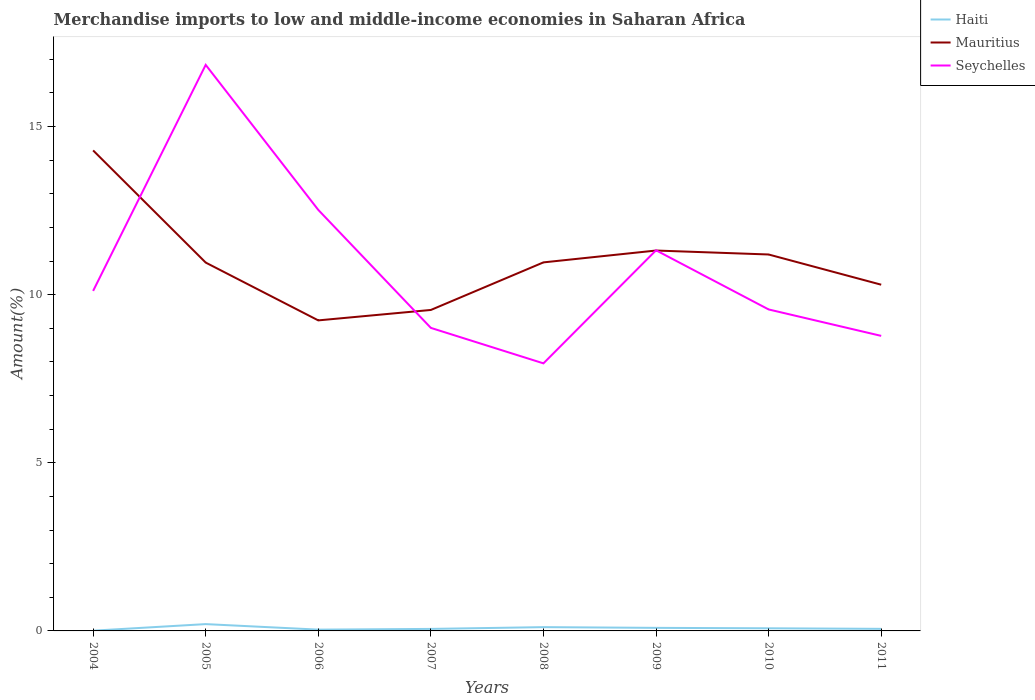How many different coloured lines are there?
Make the answer very short. 3. Does the line corresponding to Haiti intersect with the line corresponding to Seychelles?
Provide a short and direct response. No. Across all years, what is the maximum percentage of amount earned from merchandise imports in Mauritius?
Make the answer very short. 9.23. What is the total percentage of amount earned from merchandise imports in Mauritius in the graph?
Give a very brief answer. -0.24. What is the difference between the highest and the second highest percentage of amount earned from merchandise imports in Haiti?
Ensure brevity in your answer.  0.2. What is the difference between the highest and the lowest percentage of amount earned from merchandise imports in Haiti?
Offer a very short reply. 3. How many lines are there?
Provide a succinct answer. 3. How many years are there in the graph?
Your response must be concise. 8. Are the values on the major ticks of Y-axis written in scientific E-notation?
Offer a terse response. No. Does the graph contain any zero values?
Give a very brief answer. No. Does the graph contain grids?
Provide a short and direct response. No. Where does the legend appear in the graph?
Keep it short and to the point. Top right. How are the legend labels stacked?
Give a very brief answer. Vertical. What is the title of the graph?
Offer a very short reply. Merchandise imports to low and middle-income economies in Saharan Africa. What is the label or title of the Y-axis?
Make the answer very short. Amount(%). What is the Amount(%) in Haiti in 2004?
Your answer should be very brief. 0.01. What is the Amount(%) in Mauritius in 2004?
Offer a very short reply. 14.29. What is the Amount(%) of Seychelles in 2004?
Offer a very short reply. 10.11. What is the Amount(%) of Haiti in 2005?
Make the answer very short. 0.2. What is the Amount(%) in Mauritius in 2005?
Provide a short and direct response. 10.95. What is the Amount(%) of Seychelles in 2005?
Make the answer very short. 16.83. What is the Amount(%) in Haiti in 2006?
Ensure brevity in your answer.  0.04. What is the Amount(%) of Mauritius in 2006?
Make the answer very short. 9.23. What is the Amount(%) of Seychelles in 2006?
Offer a very short reply. 12.52. What is the Amount(%) in Haiti in 2007?
Keep it short and to the point. 0.06. What is the Amount(%) in Mauritius in 2007?
Ensure brevity in your answer.  9.55. What is the Amount(%) in Seychelles in 2007?
Make the answer very short. 9.01. What is the Amount(%) of Haiti in 2008?
Offer a very short reply. 0.11. What is the Amount(%) of Mauritius in 2008?
Your answer should be compact. 10.96. What is the Amount(%) of Seychelles in 2008?
Make the answer very short. 7.96. What is the Amount(%) of Haiti in 2009?
Make the answer very short. 0.09. What is the Amount(%) of Mauritius in 2009?
Offer a very short reply. 11.31. What is the Amount(%) in Seychelles in 2009?
Keep it short and to the point. 11.32. What is the Amount(%) in Haiti in 2010?
Your answer should be compact. 0.08. What is the Amount(%) in Mauritius in 2010?
Your answer should be compact. 11.19. What is the Amount(%) of Seychelles in 2010?
Give a very brief answer. 9.56. What is the Amount(%) of Haiti in 2011?
Ensure brevity in your answer.  0.06. What is the Amount(%) in Mauritius in 2011?
Offer a very short reply. 10.3. What is the Amount(%) in Seychelles in 2011?
Offer a terse response. 8.77. Across all years, what is the maximum Amount(%) in Haiti?
Offer a terse response. 0.2. Across all years, what is the maximum Amount(%) of Mauritius?
Provide a short and direct response. 14.29. Across all years, what is the maximum Amount(%) of Seychelles?
Give a very brief answer. 16.83. Across all years, what is the minimum Amount(%) in Haiti?
Make the answer very short. 0.01. Across all years, what is the minimum Amount(%) in Mauritius?
Keep it short and to the point. 9.23. Across all years, what is the minimum Amount(%) in Seychelles?
Offer a terse response. 7.96. What is the total Amount(%) in Haiti in the graph?
Make the answer very short. 0.65. What is the total Amount(%) of Mauritius in the graph?
Your answer should be compact. 87.79. What is the total Amount(%) of Seychelles in the graph?
Provide a short and direct response. 86.09. What is the difference between the Amount(%) in Haiti in 2004 and that in 2005?
Your answer should be very brief. -0.2. What is the difference between the Amount(%) of Mauritius in 2004 and that in 2005?
Keep it short and to the point. 3.34. What is the difference between the Amount(%) in Seychelles in 2004 and that in 2005?
Offer a terse response. -6.72. What is the difference between the Amount(%) in Haiti in 2004 and that in 2006?
Your answer should be compact. -0.03. What is the difference between the Amount(%) in Mauritius in 2004 and that in 2006?
Your response must be concise. 5.05. What is the difference between the Amount(%) of Seychelles in 2004 and that in 2006?
Your answer should be very brief. -2.41. What is the difference between the Amount(%) in Haiti in 2004 and that in 2007?
Give a very brief answer. -0.05. What is the difference between the Amount(%) of Mauritius in 2004 and that in 2007?
Provide a short and direct response. 4.74. What is the difference between the Amount(%) of Seychelles in 2004 and that in 2007?
Keep it short and to the point. 1.1. What is the difference between the Amount(%) in Haiti in 2004 and that in 2008?
Your answer should be compact. -0.11. What is the difference between the Amount(%) in Mauritius in 2004 and that in 2008?
Your response must be concise. 3.33. What is the difference between the Amount(%) of Seychelles in 2004 and that in 2008?
Make the answer very short. 2.15. What is the difference between the Amount(%) in Haiti in 2004 and that in 2009?
Make the answer very short. -0.08. What is the difference between the Amount(%) of Mauritius in 2004 and that in 2009?
Give a very brief answer. 2.98. What is the difference between the Amount(%) in Seychelles in 2004 and that in 2009?
Offer a very short reply. -1.21. What is the difference between the Amount(%) in Haiti in 2004 and that in 2010?
Make the answer very short. -0.07. What is the difference between the Amount(%) of Mauritius in 2004 and that in 2010?
Your response must be concise. 3.1. What is the difference between the Amount(%) in Seychelles in 2004 and that in 2010?
Provide a succinct answer. 0.55. What is the difference between the Amount(%) of Haiti in 2004 and that in 2011?
Provide a short and direct response. -0.05. What is the difference between the Amount(%) in Mauritius in 2004 and that in 2011?
Offer a very short reply. 3.99. What is the difference between the Amount(%) in Seychelles in 2004 and that in 2011?
Ensure brevity in your answer.  1.34. What is the difference between the Amount(%) in Haiti in 2005 and that in 2006?
Ensure brevity in your answer.  0.16. What is the difference between the Amount(%) in Mauritius in 2005 and that in 2006?
Your answer should be compact. 1.72. What is the difference between the Amount(%) in Seychelles in 2005 and that in 2006?
Your answer should be very brief. 4.31. What is the difference between the Amount(%) of Haiti in 2005 and that in 2007?
Ensure brevity in your answer.  0.14. What is the difference between the Amount(%) in Mauritius in 2005 and that in 2007?
Offer a very short reply. 1.41. What is the difference between the Amount(%) of Seychelles in 2005 and that in 2007?
Your answer should be very brief. 7.82. What is the difference between the Amount(%) in Haiti in 2005 and that in 2008?
Make the answer very short. 0.09. What is the difference between the Amount(%) in Mauritius in 2005 and that in 2008?
Your answer should be compact. -0.01. What is the difference between the Amount(%) in Seychelles in 2005 and that in 2008?
Make the answer very short. 8.88. What is the difference between the Amount(%) in Haiti in 2005 and that in 2009?
Ensure brevity in your answer.  0.11. What is the difference between the Amount(%) of Mauritius in 2005 and that in 2009?
Keep it short and to the point. -0.36. What is the difference between the Amount(%) in Seychelles in 2005 and that in 2009?
Your response must be concise. 5.51. What is the difference between the Amount(%) in Haiti in 2005 and that in 2010?
Provide a short and direct response. 0.12. What is the difference between the Amount(%) of Mauritius in 2005 and that in 2010?
Provide a short and direct response. -0.24. What is the difference between the Amount(%) in Seychelles in 2005 and that in 2010?
Offer a terse response. 7.27. What is the difference between the Amount(%) in Haiti in 2005 and that in 2011?
Make the answer very short. 0.14. What is the difference between the Amount(%) in Mauritius in 2005 and that in 2011?
Keep it short and to the point. 0.66. What is the difference between the Amount(%) in Seychelles in 2005 and that in 2011?
Your answer should be very brief. 8.06. What is the difference between the Amount(%) of Haiti in 2006 and that in 2007?
Offer a very short reply. -0.02. What is the difference between the Amount(%) in Mauritius in 2006 and that in 2007?
Offer a terse response. -0.31. What is the difference between the Amount(%) in Seychelles in 2006 and that in 2007?
Give a very brief answer. 3.51. What is the difference between the Amount(%) in Haiti in 2006 and that in 2008?
Keep it short and to the point. -0.07. What is the difference between the Amount(%) in Mauritius in 2006 and that in 2008?
Offer a very short reply. -1.73. What is the difference between the Amount(%) of Seychelles in 2006 and that in 2008?
Give a very brief answer. 4.56. What is the difference between the Amount(%) of Haiti in 2006 and that in 2009?
Ensure brevity in your answer.  -0.05. What is the difference between the Amount(%) in Mauritius in 2006 and that in 2009?
Offer a very short reply. -2.08. What is the difference between the Amount(%) in Seychelles in 2006 and that in 2009?
Offer a very short reply. 1.2. What is the difference between the Amount(%) in Haiti in 2006 and that in 2010?
Make the answer very short. -0.04. What is the difference between the Amount(%) in Mauritius in 2006 and that in 2010?
Your answer should be very brief. -1.96. What is the difference between the Amount(%) of Seychelles in 2006 and that in 2010?
Ensure brevity in your answer.  2.96. What is the difference between the Amount(%) of Haiti in 2006 and that in 2011?
Provide a succinct answer. -0.02. What is the difference between the Amount(%) in Mauritius in 2006 and that in 2011?
Make the answer very short. -1.06. What is the difference between the Amount(%) in Seychelles in 2006 and that in 2011?
Offer a very short reply. 3.75. What is the difference between the Amount(%) of Haiti in 2007 and that in 2008?
Your response must be concise. -0.05. What is the difference between the Amount(%) of Mauritius in 2007 and that in 2008?
Ensure brevity in your answer.  -1.41. What is the difference between the Amount(%) of Seychelles in 2007 and that in 2008?
Keep it short and to the point. 1.05. What is the difference between the Amount(%) in Haiti in 2007 and that in 2009?
Make the answer very short. -0.03. What is the difference between the Amount(%) in Mauritius in 2007 and that in 2009?
Provide a short and direct response. -1.77. What is the difference between the Amount(%) of Seychelles in 2007 and that in 2009?
Your answer should be very brief. -2.31. What is the difference between the Amount(%) in Haiti in 2007 and that in 2010?
Your answer should be very brief. -0.02. What is the difference between the Amount(%) in Mauritius in 2007 and that in 2010?
Ensure brevity in your answer.  -1.65. What is the difference between the Amount(%) of Seychelles in 2007 and that in 2010?
Your response must be concise. -0.55. What is the difference between the Amount(%) in Haiti in 2007 and that in 2011?
Offer a very short reply. -0. What is the difference between the Amount(%) of Mauritius in 2007 and that in 2011?
Provide a succinct answer. -0.75. What is the difference between the Amount(%) of Seychelles in 2007 and that in 2011?
Your answer should be very brief. 0.24. What is the difference between the Amount(%) in Haiti in 2008 and that in 2009?
Keep it short and to the point. 0.02. What is the difference between the Amount(%) of Mauritius in 2008 and that in 2009?
Offer a terse response. -0.35. What is the difference between the Amount(%) in Seychelles in 2008 and that in 2009?
Give a very brief answer. -3.36. What is the difference between the Amount(%) of Haiti in 2008 and that in 2010?
Offer a terse response. 0.03. What is the difference between the Amount(%) in Mauritius in 2008 and that in 2010?
Your response must be concise. -0.23. What is the difference between the Amount(%) of Seychelles in 2008 and that in 2010?
Your answer should be compact. -1.6. What is the difference between the Amount(%) in Haiti in 2008 and that in 2011?
Keep it short and to the point. 0.05. What is the difference between the Amount(%) in Mauritius in 2008 and that in 2011?
Give a very brief answer. 0.66. What is the difference between the Amount(%) in Seychelles in 2008 and that in 2011?
Your answer should be very brief. -0.82. What is the difference between the Amount(%) of Haiti in 2009 and that in 2010?
Provide a short and direct response. 0.01. What is the difference between the Amount(%) in Mauritius in 2009 and that in 2010?
Offer a very short reply. 0.12. What is the difference between the Amount(%) in Seychelles in 2009 and that in 2010?
Give a very brief answer. 1.76. What is the difference between the Amount(%) in Haiti in 2009 and that in 2011?
Your answer should be compact. 0.03. What is the difference between the Amount(%) in Mauritius in 2009 and that in 2011?
Make the answer very short. 1.02. What is the difference between the Amount(%) of Seychelles in 2009 and that in 2011?
Keep it short and to the point. 2.55. What is the difference between the Amount(%) of Haiti in 2010 and that in 2011?
Ensure brevity in your answer.  0.02. What is the difference between the Amount(%) of Mauritius in 2010 and that in 2011?
Provide a short and direct response. 0.9. What is the difference between the Amount(%) in Seychelles in 2010 and that in 2011?
Make the answer very short. 0.79. What is the difference between the Amount(%) in Haiti in 2004 and the Amount(%) in Mauritius in 2005?
Your answer should be compact. -10.95. What is the difference between the Amount(%) in Haiti in 2004 and the Amount(%) in Seychelles in 2005?
Offer a terse response. -16.83. What is the difference between the Amount(%) in Mauritius in 2004 and the Amount(%) in Seychelles in 2005?
Offer a terse response. -2.54. What is the difference between the Amount(%) in Haiti in 2004 and the Amount(%) in Mauritius in 2006?
Your answer should be very brief. -9.23. What is the difference between the Amount(%) in Haiti in 2004 and the Amount(%) in Seychelles in 2006?
Provide a short and direct response. -12.51. What is the difference between the Amount(%) in Mauritius in 2004 and the Amount(%) in Seychelles in 2006?
Offer a very short reply. 1.77. What is the difference between the Amount(%) in Haiti in 2004 and the Amount(%) in Mauritius in 2007?
Give a very brief answer. -9.54. What is the difference between the Amount(%) of Haiti in 2004 and the Amount(%) of Seychelles in 2007?
Keep it short and to the point. -9. What is the difference between the Amount(%) in Mauritius in 2004 and the Amount(%) in Seychelles in 2007?
Your answer should be very brief. 5.28. What is the difference between the Amount(%) of Haiti in 2004 and the Amount(%) of Mauritius in 2008?
Offer a very short reply. -10.95. What is the difference between the Amount(%) in Haiti in 2004 and the Amount(%) in Seychelles in 2008?
Your answer should be very brief. -7.95. What is the difference between the Amount(%) in Mauritius in 2004 and the Amount(%) in Seychelles in 2008?
Keep it short and to the point. 6.33. What is the difference between the Amount(%) of Haiti in 2004 and the Amount(%) of Mauritius in 2009?
Your answer should be very brief. -11.3. What is the difference between the Amount(%) of Haiti in 2004 and the Amount(%) of Seychelles in 2009?
Your answer should be very brief. -11.31. What is the difference between the Amount(%) in Mauritius in 2004 and the Amount(%) in Seychelles in 2009?
Your answer should be compact. 2.97. What is the difference between the Amount(%) of Haiti in 2004 and the Amount(%) of Mauritius in 2010?
Give a very brief answer. -11.19. What is the difference between the Amount(%) in Haiti in 2004 and the Amount(%) in Seychelles in 2010?
Give a very brief answer. -9.55. What is the difference between the Amount(%) of Mauritius in 2004 and the Amount(%) of Seychelles in 2010?
Make the answer very short. 4.73. What is the difference between the Amount(%) in Haiti in 2004 and the Amount(%) in Mauritius in 2011?
Offer a very short reply. -10.29. What is the difference between the Amount(%) of Haiti in 2004 and the Amount(%) of Seychelles in 2011?
Your response must be concise. -8.77. What is the difference between the Amount(%) in Mauritius in 2004 and the Amount(%) in Seychelles in 2011?
Ensure brevity in your answer.  5.52. What is the difference between the Amount(%) of Haiti in 2005 and the Amount(%) of Mauritius in 2006?
Keep it short and to the point. -9.03. What is the difference between the Amount(%) in Haiti in 2005 and the Amount(%) in Seychelles in 2006?
Offer a very short reply. -12.32. What is the difference between the Amount(%) of Mauritius in 2005 and the Amount(%) of Seychelles in 2006?
Make the answer very short. -1.57. What is the difference between the Amount(%) of Haiti in 2005 and the Amount(%) of Mauritius in 2007?
Offer a terse response. -9.34. What is the difference between the Amount(%) of Haiti in 2005 and the Amount(%) of Seychelles in 2007?
Ensure brevity in your answer.  -8.81. What is the difference between the Amount(%) of Mauritius in 2005 and the Amount(%) of Seychelles in 2007?
Your answer should be very brief. 1.94. What is the difference between the Amount(%) in Haiti in 2005 and the Amount(%) in Mauritius in 2008?
Make the answer very short. -10.76. What is the difference between the Amount(%) in Haiti in 2005 and the Amount(%) in Seychelles in 2008?
Your answer should be very brief. -7.75. What is the difference between the Amount(%) in Mauritius in 2005 and the Amount(%) in Seychelles in 2008?
Provide a succinct answer. 3. What is the difference between the Amount(%) of Haiti in 2005 and the Amount(%) of Mauritius in 2009?
Keep it short and to the point. -11.11. What is the difference between the Amount(%) in Haiti in 2005 and the Amount(%) in Seychelles in 2009?
Provide a succinct answer. -11.12. What is the difference between the Amount(%) of Mauritius in 2005 and the Amount(%) of Seychelles in 2009?
Offer a very short reply. -0.36. What is the difference between the Amount(%) of Haiti in 2005 and the Amount(%) of Mauritius in 2010?
Offer a terse response. -10.99. What is the difference between the Amount(%) of Haiti in 2005 and the Amount(%) of Seychelles in 2010?
Offer a very short reply. -9.36. What is the difference between the Amount(%) in Mauritius in 2005 and the Amount(%) in Seychelles in 2010?
Your answer should be compact. 1.39. What is the difference between the Amount(%) in Haiti in 2005 and the Amount(%) in Mauritius in 2011?
Make the answer very short. -10.09. What is the difference between the Amount(%) of Haiti in 2005 and the Amount(%) of Seychelles in 2011?
Your answer should be compact. -8.57. What is the difference between the Amount(%) of Mauritius in 2005 and the Amount(%) of Seychelles in 2011?
Your answer should be compact. 2.18. What is the difference between the Amount(%) in Haiti in 2006 and the Amount(%) in Mauritius in 2007?
Make the answer very short. -9.51. What is the difference between the Amount(%) of Haiti in 2006 and the Amount(%) of Seychelles in 2007?
Offer a very short reply. -8.97. What is the difference between the Amount(%) of Mauritius in 2006 and the Amount(%) of Seychelles in 2007?
Give a very brief answer. 0.22. What is the difference between the Amount(%) of Haiti in 2006 and the Amount(%) of Mauritius in 2008?
Offer a very short reply. -10.92. What is the difference between the Amount(%) in Haiti in 2006 and the Amount(%) in Seychelles in 2008?
Make the answer very short. -7.92. What is the difference between the Amount(%) in Mauritius in 2006 and the Amount(%) in Seychelles in 2008?
Provide a succinct answer. 1.28. What is the difference between the Amount(%) in Haiti in 2006 and the Amount(%) in Mauritius in 2009?
Offer a terse response. -11.27. What is the difference between the Amount(%) of Haiti in 2006 and the Amount(%) of Seychelles in 2009?
Your response must be concise. -11.28. What is the difference between the Amount(%) of Mauritius in 2006 and the Amount(%) of Seychelles in 2009?
Offer a very short reply. -2.08. What is the difference between the Amount(%) in Haiti in 2006 and the Amount(%) in Mauritius in 2010?
Provide a succinct answer. -11.16. What is the difference between the Amount(%) in Haiti in 2006 and the Amount(%) in Seychelles in 2010?
Keep it short and to the point. -9.52. What is the difference between the Amount(%) of Mauritius in 2006 and the Amount(%) of Seychelles in 2010?
Your response must be concise. -0.33. What is the difference between the Amount(%) of Haiti in 2006 and the Amount(%) of Mauritius in 2011?
Ensure brevity in your answer.  -10.26. What is the difference between the Amount(%) of Haiti in 2006 and the Amount(%) of Seychelles in 2011?
Give a very brief answer. -8.74. What is the difference between the Amount(%) of Mauritius in 2006 and the Amount(%) of Seychelles in 2011?
Ensure brevity in your answer.  0.46. What is the difference between the Amount(%) of Haiti in 2007 and the Amount(%) of Mauritius in 2008?
Your answer should be very brief. -10.9. What is the difference between the Amount(%) in Haiti in 2007 and the Amount(%) in Seychelles in 2008?
Your response must be concise. -7.9. What is the difference between the Amount(%) in Mauritius in 2007 and the Amount(%) in Seychelles in 2008?
Keep it short and to the point. 1.59. What is the difference between the Amount(%) in Haiti in 2007 and the Amount(%) in Mauritius in 2009?
Offer a terse response. -11.25. What is the difference between the Amount(%) in Haiti in 2007 and the Amount(%) in Seychelles in 2009?
Ensure brevity in your answer.  -11.26. What is the difference between the Amount(%) in Mauritius in 2007 and the Amount(%) in Seychelles in 2009?
Offer a very short reply. -1.77. What is the difference between the Amount(%) of Haiti in 2007 and the Amount(%) of Mauritius in 2010?
Your answer should be very brief. -11.13. What is the difference between the Amount(%) in Haiti in 2007 and the Amount(%) in Seychelles in 2010?
Keep it short and to the point. -9.5. What is the difference between the Amount(%) of Mauritius in 2007 and the Amount(%) of Seychelles in 2010?
Offer a terse response. -0.02. What is the difference between the Amount(%) in Haiti in 2007 and the Amount(%) in Mauritius in 2011?
Give a very brief answer. -10.24. What is the difference between the Amount(%) of Haiti in 2007 and the Amount(%) of Seychelles in 2011?
Provide a short and direct response. -8.71. What is the difference between the Amount(%) in Mauritius in 2007 and the Amount(%) in Seychelles in 2011?
Ensure brevity in your answer.  0.77. What is the difference between the Amount(%) in Haiti in 2008 and the Amount(%) in Mauritius in 2009?
Offer a terse response. -11.2. What is the difference between the Amount(%) in Haiti in 2008 and the Amount(%) in Seychelles in 2009?
Provide a succinct answer. -11.21. What is the difference between the Amount(%) of Mauritius in 2008 and the Amount(%) of Seychelles in 2009?
Your response must be concise. -0.36. What is the difference between the Amount(%) in Haiti in 2008 and the Amount(%) in Mauritius in 2010?
Offer a terse response. -11.08. What is the difference between the Amount(%) in Haiti in 2008 and the Amount(%) in Seychelles in 2010?
Make the answer very short. -9.45. What is the difference between the Amount(%) of Mauritius in 2008 and the Amount(%) of Seychelles in 2010?
Ensure brevity in your answer.  1.4. What is the difference between the Amount(%) in Haiti in 2008 and the Amount(%) in Mauritius in 2011?
Provide a short and direct response. -10.18. What is the difference between the Amount(%) of Haiti in 2008 and the Amount(%) of Seychelles in 2011?
Your answer should be compact. -8.66. What is the difference between the Amount(%) in Mauritius in 2008 and the Amount(%) in Seychelles in 2011?
Your answer should be compact. 2.19. What is the difference between the Amount(%) of Haiti in 2009 and the Amount(%) of Mauritius in 2010?
Provide a succinct answer. -11.1. What is the difference between the Amount(%) in Haiti in 2009 and the Amount(%) in Seychelles in 2010?
Provide a succinct answer. -9.47. What is the difference between the Amount(%) of Mauritius in 2009 and the Amount(%) of Seychelles in 2010?
Your answer should be compact. 1.75. What is the difference between the Amount(%) of Haiti in 2009 and the Amount(%) of Mauritius in 2011?
Give a very brief answer. -10.2. What is the difference between the Amount(%) of Haiti in 2009 and the Amount(%) of Seychelles in 2011?
Offer a very short reply. -8.68. What is the difference between the Amount(%) of Mauritius in 2009 and the Amount(%) of Seychelles in 2011?
Offer a very short reply. 2.54. What is the difference between the Amount(%) in Haiti in 2010 and the Amount(%) in Mauritius in 2011?
Your response must be concise. -10.22. What is the difference between the Amount(%) of Haiti in 2010 and the Amount(%) of Seychelles in 2011?
Offer a terse response. -8.7. What is the difference between the Amount(%) of Mauritius in 2010 and the Amount(%) of Seychelles in 2011?
Keep it short and to the point. 2.42. What is the average Amount(%) in Haiti per year?
Make the answer very short. 0.08. What is the average Amount(%) in Mauritius per year?
Ensure brevity in your answer.  10.97. What is the average Amount(%) in Seychelles per year?
Your answer should be compact. 10.76. In the year 2004, what is the difference between the Amount(%) of Haiti and Amount(%) of Mauritius?
Make the answer very short. -14.28. In the year 2004, what is the difference between the Amount(%) of Haiti and Amount(%) of Seychelles?
Offer a very short reply. -10.1. In the year 2004, what is the difference between the Amount(%) of Mauritius and Amount(%) of Seychelles?
Your answer should be compact. 4.18. In the year 2005, what is the difference between the Amount(%) in Haiti and Amount(%) in Mauritius?
Give a very brief answer. -10.75. In the year 2005, what is the difference between the Amount(%) of Haiti and Amount(%) of Seychelles?
Offer a very short reply. -16.63. In the year 2005, what is the difference between the Amount(%) in Mauritius and Amount(%) in Seychelles?
Give a very brief answer. -5.88. In the year 2006, what is the difference between the Amount(%) in Haiti and Amount(%) in Mauritius?
Ensure brevity in your answer.  -9.2. In the year 2006, what is the difference between the Amount(%) in Haiti and Amount(%) in Seychelles?
Your answer should be compact. -12.48. In the year 2006, what is the difference between the Amount(%) of Mauritius and Amount(%) of Seychelles?
Keep it short and to the point. -3.29. In the year 2007, what is the difference between the Amount(%) of Haiti and Amount(%) of Mauritius?
Offer a terse response. -9.49. In the year 2007, what is the difference between the Amount(%) of Haiti and Amount(%) of Seychelles?
Your response must be concise. -8.95. In the year 2007, what is the difference between the Amount(%) in Mauritius and Amount(%) in Seychelles?
Keep it short and to the point. 0.53. In the year 2008, what is the difference between the Amount(%) of Haiti and Amount(%) of Mauritius?
Give a very brief answer. -10.85. In the year 2008, what is the difference between the Amount(%) in Haiti and Amount(%) in Seychelles?
Provide a short and direct response. -7.84. In the year 2008, what is the difference between the Amount(%) of Mauritius and Amount(%) of Seychelles?
Your answer should be compact. 3. In the year 2009, what is the difference between the Amount(%) of Haiti and Amount(%) of Mauritius?
Offer a very short reply. -11.22. In the year 2009, what is the difference between the Amount(%) in Haiti and Amount(%) in Seychelles?
Your answer should be compact. -11.23. In the year 2009, what is the difference between the Amount(%) of Mauritius and Amount(%) of Seychelles?
Keep it short and to the point. -0.01. In the year 2010, what is the difference between the Amount(%) of Haiti and Amount(%) of Mauritius?
Your answer should be compact. -11.12. In the year 2010, what is the difference between the Amount(%) of Haiti and Amount(%) of Seychelles?
Ensure brevity in your answer.  -9.48. In the year 2010, what is the difference between the Amount(%) of Mauritius and Amount(%) of Seychelles?
Provide a short and direct response. 1.63. In the year 2011, what is the difference between the Amount(%) of Haiti and Amount(%) of Mauritius?
Your response must be concise. -10.23. In the year 2011, what is the difference between the Amount(%) in Haiti and Amount(%) in Seychelles?
Provide a succinct answer. -8.71. In the year 2011, what is the difference between the Amount(%) of Mauritius and Amount(%) of Seychelles?
Offer a terse response. 1.52. What is the ratio of the Amount(%) of Haiti in 2004 to that in 2005?
Your response must be concise. 0.04. What is the ratio of the Amount(%) of Mauritius in 2004 to that in 2005?
Give a very brief answer. 1.3. What is the ratio of the Amount(%) of Seychelles in 2004 to that in 2005?
Your answer should be compact. 0.6. What is the ratio of the Amount(%) of Haiti in 2004 to that in 2006?
Offer a terse response. 0.19. What is the ratio of the Amount(%) in Mauritius in 2004 to that in 2006?
Provide a succinct answer. 1.55. What is the ratio of the Amount(%) of Seychelles in 2004 to that in 2006?
Give a very brief answer. 0.81. What is the ratio of the Amount(%) of Haiti in 2004 to that in 2007?
Give a very brief answer. 0.12. What is the ratio of the Amount(%) in Mauritius in 2004 to that in 2007?
Offer a very short reply. 1.5. What is the ratio of the Amount(%) of Seychelles in 2004 to that in 2007?
Keep it short and to the point. 1.12. What is the ratio of the Amount(%) in Haiti in 2004 to that in 2008?
Provide a short and direct response. 0.06. What is the ratio of the Amount(%) in Mauritius in 2004 to that in 2008?
Your answer should be very brief. 1.3. What is the ratio of the Amount(%) of Seychelles in 2004 to that in 2008?
Provide a succinct answer. 1.27. What is the ratio of the Amount(%) of Haiti in 2004 to that in 2009?
Ensure brevity in your answer.  0.08. What is the ratio of the Amount(%) of Mauritius in 2004 to that in 2009?
Offer a terse response. 1.26. What is the ratio of the Amount(%) of Seychelles in 2004 to that in 2009?
Your answer should be compact. 0.89. What is the ratio of the Amount(%) in Haiti in 2004 to that in 2010?
Your answer should be very brief. 0.09. What is the ratio of the Amount(%) in Mauritius in 2004 to that in 2010?
Make the answer very short. 1.28. What is the ratio of the Amount(%) of Seychelles in 2004 to that in 2010?
Offer a terse response. 1.06. What is the ratio of the Amount(%) in Haiti in 2004 to that in 2011?
Your answer should be very brief. 0.12. What is the ratio of the Amount(%) of Mauritius in 2004 to that in 2011?
Provide a short and direct response. 1.39. What is the ratio of the Amount(%) in Seychelles in 2004 to that in 2011?
Offer a terse response. 1.15. What is the ratio of the Amount(%) of Haiti in 2005 to that in 2006?
Ensure brevity in your answer.  5.26. What is the ratio of the Amount(%) of Mauritius in 2005 to that in 2006?
Ensure brevity in your answer.  1.19. What is the ratio of the Amount(%) in Seychelles in 2005 to that in 2006?
Provide a succinct answer. 1.34. What is the ratio of the Amount(%) in Haiti in 2005 to that in 2007?
Your answer should be compact. 3.39. What is the ratio of the Amount(%) in Mauritius in 2005 to that in 2007?
Provide a succinct answer. 1.15. What is the ratio of the Amount(%) in Seychelles in 2005 to that in 2007?
Offer a very short reply. 1.87. What is the ratio of the Amount(%) of Haiti in 2005 to that in 2008?
Provide a short and direct response. 1.8. What is the ratio of the Amount(%) in Mauritius in 2005 to that in 2008?
Ensure brevity in your answer.  1. What is the ratio of the Amount(%) of Seychelles in 2005 to that in 2008?
Your response must be concise. 2.12. What is the ratio of the Amount(%) in Haiti in 2005 to that in 2009?
Offer a very short reply. 2.22. What is the ratio of the Amount(%) in Mauritius in 2005 to that in 2009?
Your answer should be compact. 0.97. What is the ratio of the Amount(%) of Seychelles in 2005 to that in 2009?
Your response must be concise. 1.49. What is the ratio of the Amount(%) of Haiti in 2005 to that in 2010?
Your answer should be very brief. 2.6. What is the ratio of the Amount(%) in Mauritius in 2005 to that in 2010?
Offer a terse response. 0.98. What is the ratio of the Amount(%) of Seychelles in 2005 to that in 2010?
Provide a short and direct response. 1.76. What is the ratio of the Amount(%) of Haiti in 2005 to that in 2011?
Your answer should be compact. 3.29. What is the ratio of the Amount(%) of Mauritius in 2005 to that in 2011?
Give a very brief answer. 1.06. What is the ratio of the Amount(%) in Seychelles in 2005 to that in 2011?
Provide a short and direct response. 1.92. What is the ratio of the Amount(%) of Haiti in 2006 to that in 2007?
Keep it short and to the point. 0.65. What is the ratio of the Amount(%) of Mauritius in 2006 to that in 2007?
Give a very brief answer. 0.97. What is the ratio of the Amount(%) in Seychelles in 2006 to that in 2007?
Ensure brevity in your answer.  1.39. What is the ratio of the Amount(%) in Haiti in 2006 to that in 2008?
Ensure brevity in your answer.  0.34. What is the ratio of the Amount(%) in Mauritius in 2006 to that in 2008?
Provide a succinct answer. 0.84. What is the ratio of the Amount(%) in Seychelles in 2006 to that in 2008?
Offer a very short reply. 1.57. What is the ratio of the Amount(%) in Haiti in 2006 to that in 2009?
Offer a very short reply. 0.42. What is the ratio of the Amount(%) in Mauritius in 2006 to that in 2009?
Provide a short and direct response. 0.82. What is the ratio of the Amount(%) of Seychelles in 2006 to that in 2009?
Offer a terse response. 1.11. What is the ratio of the Amount(%) in Haiti in 2006 to that in 2010?
Keep it short and to the point. 0.49. What is the ratio of the Amount(%) in Mauritius in 2006 to that in 2010?
Offer a terse response. 0.82. What is the ratio of the Amount(%) in Seychelles in 2006 to that in 2010?
Provide a short and direct response. 1.31. What is the ratio of the Amount(%) of Haiti in 2006 to that in 2011?
Give a very brief answer. 0.63. What is the ratio of the Amount(%) of Mauritius in 2006 to that in 2011?
Ensure brevity in your answer.  0.9. What is the ratio of the Amount(%) of Seychelles in 2006 to that in 2011?
Give a very brief answer. 1.43. What is the ratio of the Amount(%) in Haiti in 2007 to that in 2008?
Your answer should be compact. 0.53. What is the ratio of the Amount(%) in Mauritius in 2007 to that in 2008?
Provide a succinct answer. 0.87. What is the ratio of the Amount(%) in Seychelles in 2007 to that in 2008?
Keep it short and to the point. 1.13. What is the ratio of the Amount(%) of Haiti in 2007 to that in 2009?
Make the answer very short. 0.65. What is the ratio of the Amount(%) of Mauritius in 2007 to that in 2009?
Your answer should be very brief. 0.84. What is the ratio of the Amount(%) of Seychelles in 2007 to that in 2009?
Provide a short and direct response. 0.8. What is the ratio of the Amount(%) in Haiti in 2007 to that in 2010?
Make the answer very short. 0.76. What is the ratio of the Amount(%) in Mauritius in 2007 to that in 2010?
Your answer should be compact. 0.85. What is the ratio of the Amount(%) in Seychelles in 2007 to that in 2010?
Provide a short and direct response. 0.94. What is the ratio of the Amount(%) of Haiti in 2007 to that in 2011?
Your answer should be very brief. 0.97. What is the ratio of the Amount(%) in Mauritius in 2007 to that in 2011?
Your response must be concise. 0.93. What is the ratio of the Amount(%) in Seychelles in 2007 to that in 2011?
Provide a succinct answer. 1.03. What is the ratio of the Amount(%) in Haiti in 2008 to that in 2009?
Provide a succinct answer. 1.23. What is the ratio of the Amount(%) in Mauritius in 2008 to that in 2009?
Keep it short and to the point. 0.97. What is the ratio of the Amount(%) of Seychelles in 2008 to that in 2009?
Offer a very short reply. 0.7. What is the ratio of the Amount(%) in Haiti in 2008 to that in 2010?
Offer a very short reply. 1.44. What is the ratio of the Amount(%) in Seychelles in 2008 to that in 2010?
Your answer should be very brief. 0.83. What is the ratio of the Amount(%) in Haiti in 2008 to that in 2011?
Offer a very short reply. 1.83. What is the ratio of the Amount(%) of Mauritius in 2008 to that in 2011?
Make the answer very short. 1.06. What is the ratio of the Amount(%) in Seychelles in 2008 to that in 2011?
Provide a short and direct response. 0.91. What is the ratio of the Amount(%) in Haiti in 2009 to that in 2010?
Your response must be concise. 1.17. What is the ratio of the Amount(%) of Mauritius in 2009 to that in 2010?
Provide a short and direct response. 1.01. What is the ratio of the Amount(%) of Seychelles in 2009 to that in 2010?
Offer a terse response. 1.18. What is the ratio of the Amount(%) in Haiti in 2009 to that in 2011?
Ensure brevity in your answer.  1.48. What is the ratio of the Amount(%) in Mauritius in 2009 to that in 2011?
Offer a terse response. 1.1. What is the ratio of the Amount(%) in Seychelles in 2009 to that in 2011?
Keep it short and to the point. 1.29. What is the ratio of the Amount(%) in Haiti in 2010 to that in 2011?
Keep it short and to the point. 1.27. What is the ratio of the Amount(%) in Mauritius in 2010 to that in 2011?
Give a very brief answer. 1.09. What is the ratio of the Amount(%) in Seychelles in 2010 to that in 2011?
Make the answer very short. 1.09. What is the difference between the highest and the second highest Amount(%) in Haiti?
Offer a terse response. 0.09. What is the difference between the highest and the second highest Amount(%) in Mauritius?
Your answer should be compact. 2.98. What is the difference between the highest and the second highest Amount(%) of Seychelles?
Provide a succinct answer. 4.31. What is the difference between the highest and the lowest Amount(%) in Haiti?
Ensure brevity in your answer.  0.2. What is the difference between the highest and the lowest Amount(%) in Mauritius?
Your answer should be very brief. 5.05. What is the difference between the highest and the lowest Amount(%) of Seychelles?
Provide a short and direct response. 8.88. 